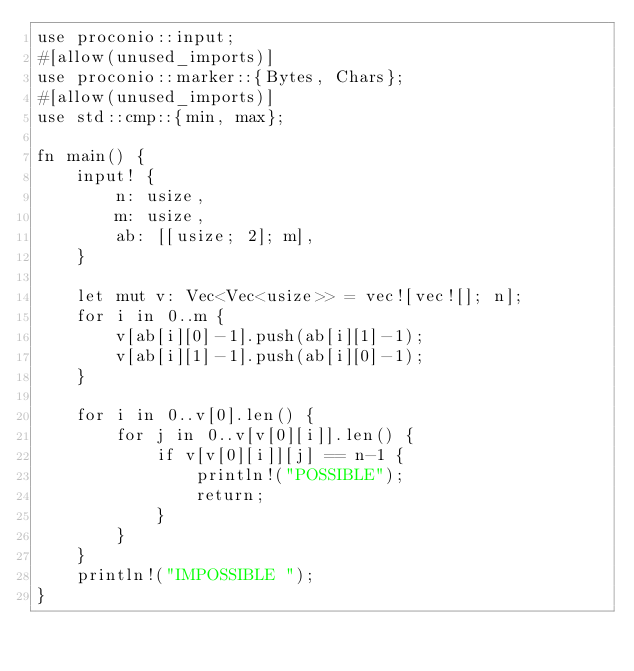<code> <loc_0><loc_0><loc_500><loc_500><_Rust_>use proconio::input;
#[allow(unused_imports)]
use proconio::marker::{Bytes, Chars};
#[allow(unused_imports)]
use std::cmp::{min, max};

fn main() {
	input! {
		n: usize,
		m: usize,
		ab: [[usize; 2]; m],
	}

	let mut v: Vec<Vec<usize>> = vec![vec![]; n];
	for i in 0..m {
		v[ab[i][0]-1].push(ab[i][1]-1);
		v[ab[i][1]-1].push(ab[i][0]-1);
	}

	for i in 0..v[0].len() {
		for j in 0..v[v[0][i]].len() {
			if v[v[0][i]][j] == n-1 {
				println!("POSSIBLE");
				return;
			}
		}
	}
	println!("IMPOSSIBLE ");
}

</code> 